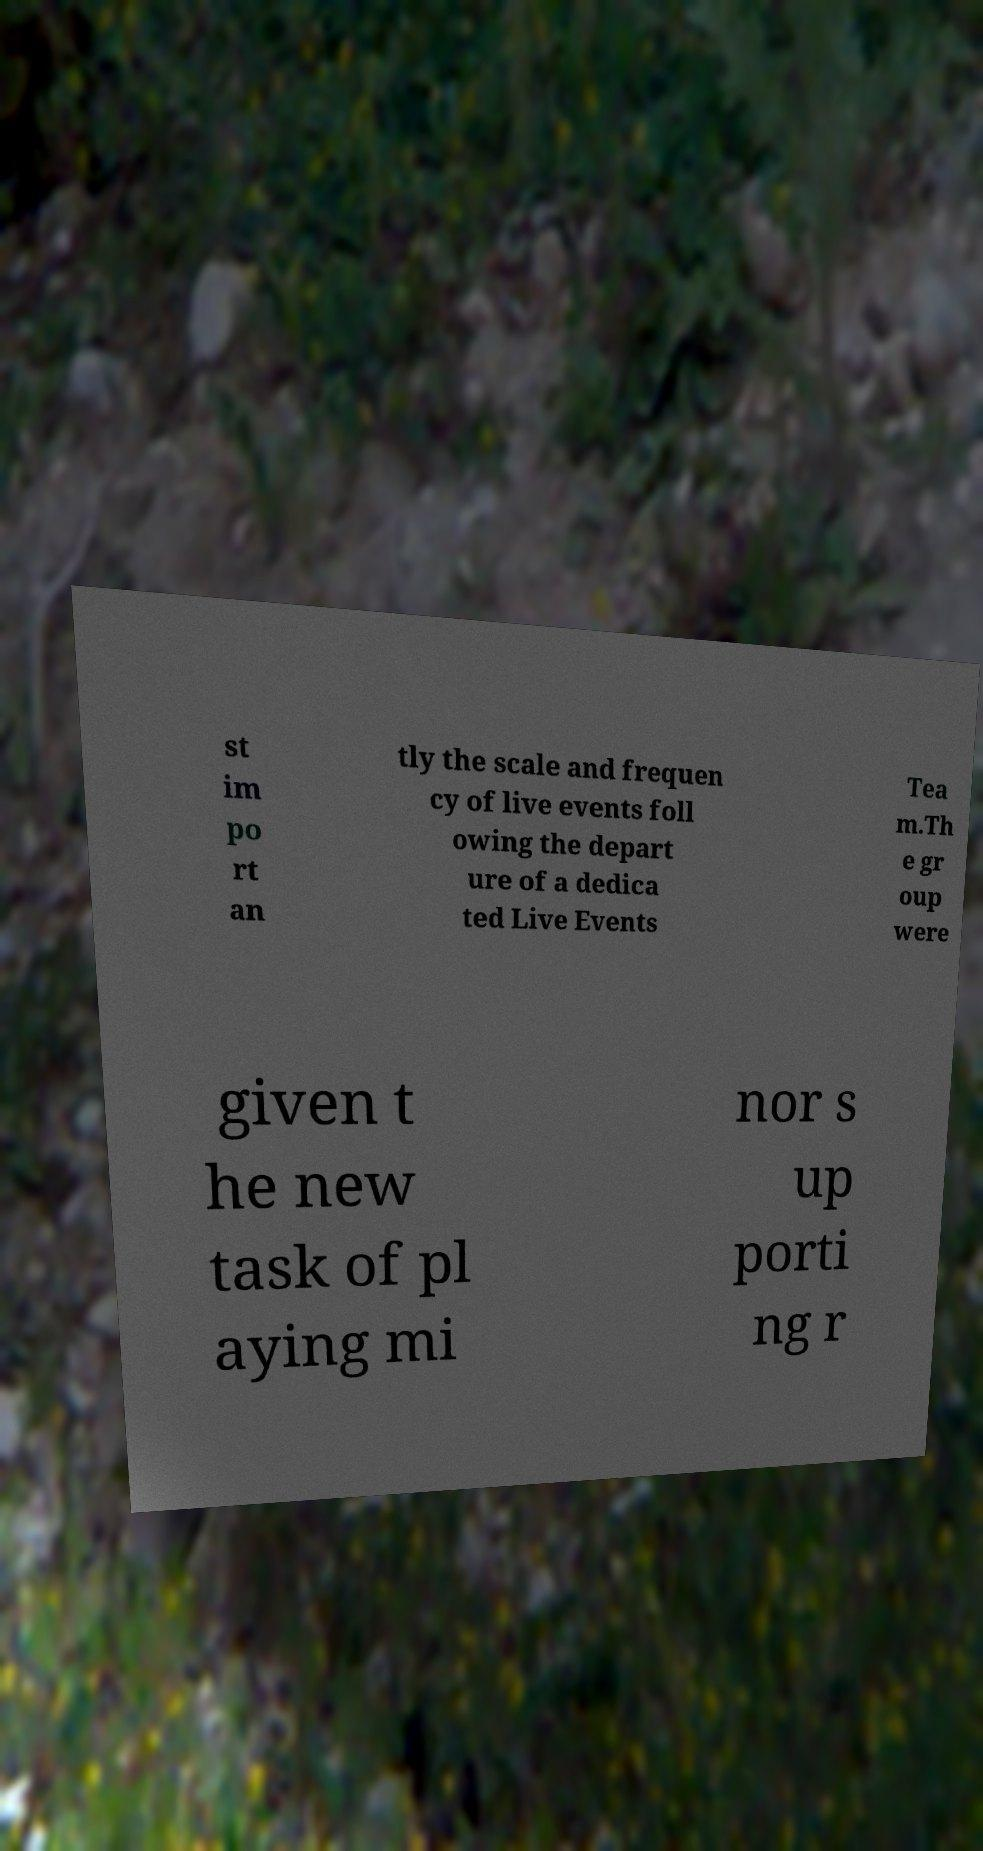What messages or text are displayed in this image? I need them in a readable, typed format. st im po rt an tly the scale and frequen cy of live events foll owing the depart ure of a dedica ted Live Events Tea m.Th e gr oup were given t he new task of pl aying mi nor s up porti ng r 